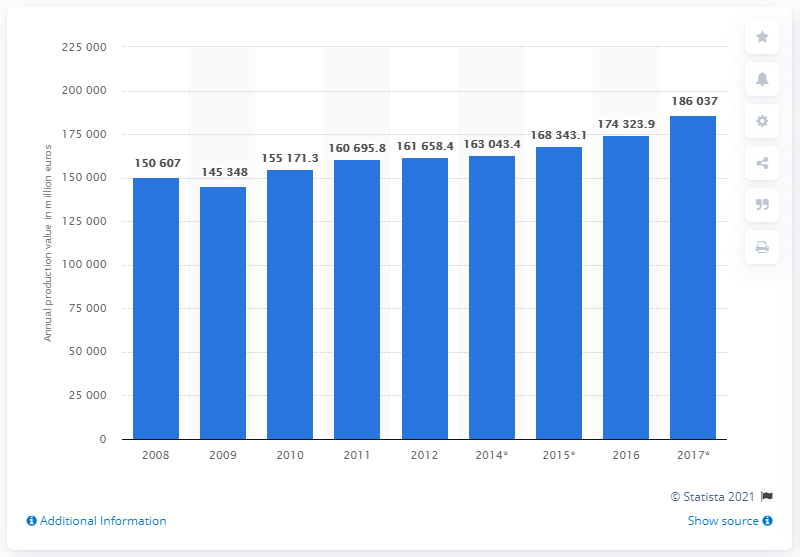Highlight a few significant elements in this photo. In 2017, the production value of the French information and communication technology sector was approximately 186,037. 